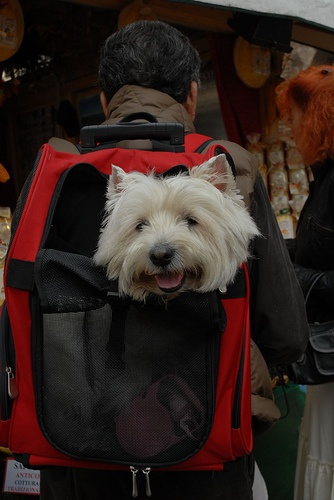Describe the objects in this image and their specific colors. I can see people in black, maroon, darkgray, and gray tones, backpack in black, maroon, darkgray, and gray tones, people in black, maroon, and gray tones, and dog in black, darkgray, and gray tones in this image. 